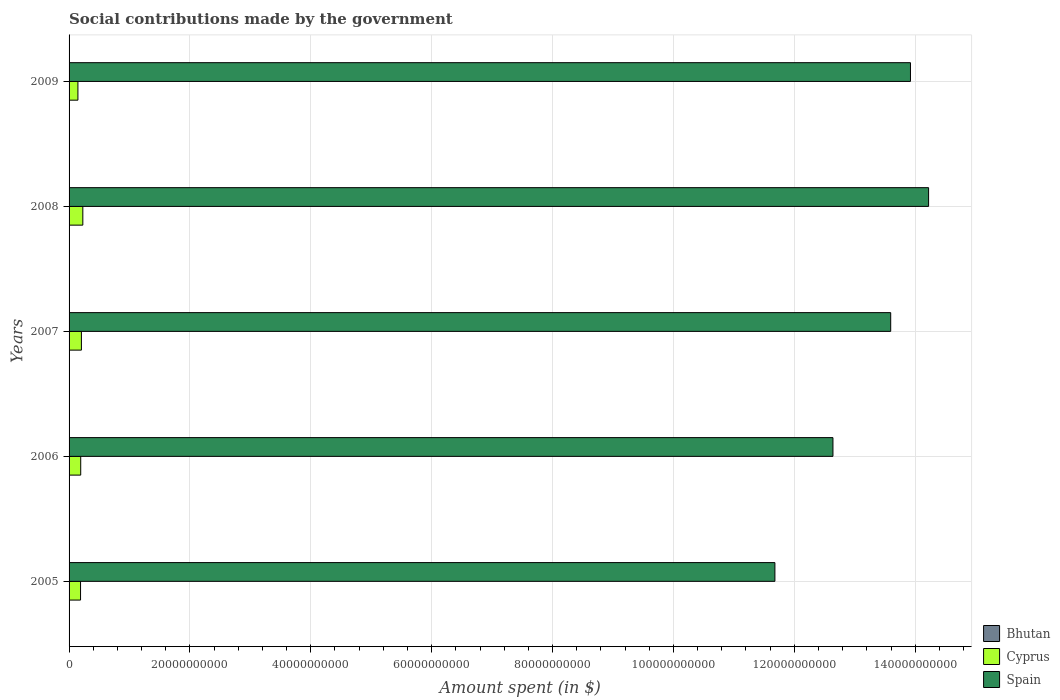How many different coloured bars are there?
Offer a terse response. 3. Are the number of bars per tick equal to the number of legend labels?
Offer a very short reply. Yes. How many bars are there on the 3rd tick from the top?
Your answer should be compact. 3. What is the amount spent on social contributions in Cyprus in 2008?
Ensure brevity in your answer.  2.28e+09. Across all years, what is the maximum amount spent on social contributions in Cyprus?
Keep it short and to the point. 2.28e+09. Across all years, what is the minimum amount spent on social contributions in Bhutan?
Provide a short and direct response. 3.60e+07. In which year was the amount spent on social contributions in Bhutan minimum?
Give a very brief answer. 2005. What is the total amount spent on social contributions in Spain in the graph?
Offer a very short reply. 6.61e+11. What is the difference between the amount spent on social contributions in Cyprus in 2008 and that in 2009?
Provide a short and direct response. 8.13e+08. What is the difference between the amount spent on social contributions in Bhutan in 2006 and the amount spent on social contributions in Cyprus in 2005?
Give a very brief answer. -1.85e+09. What is the average amount spent on social contributions in Spain per year?
Provide a succinct answer. 1.32e+11. In the year 2006, what is the difference between the amount spent on social contributions in Bhutan and amount spent on social contributions in Cyprus?
Provide a short and direct response. -1.88e+09. In how many years, is the amount spent on social contributions in Spain greater than 12000000000 $?
Your answer should be compact. 5. What is the ratio of the amount spent on social contributions in Bhutan in 2006 to that in 2007?
Offer a very short reply. 0.89. Is the amount spent on social contributions in Bhutan in 2006 less than that in 2007?
Provide a succinct answer. Yes. What is the difference between the highest and the second highest amount spent on social contributions in Cyprus?
Make the answer very short. 2.35e+08. What is the difference between the highest and the lowest amount spent on social contributions in Bhutan?
Your answer should be very brief. 3.53e+07. In how many years, is the amount spent on social contributions in Spain greater than the average amount spent on social contributions in Spain taken over all years?
Provide a short and direct response. 3. Is the sum of the amount spent on social contributions in Cyprus in 2005 and 2009 greater than the maximum amount spent on social contributions in Bhutan across all years?
Your answer should be compact. Yes. What does the 1st bar from the top in 2006 represents?
Your answer should be very brief. Spain. How many bars are there?
Make the answer very short. 15. Are all the bars in the graph horizontal?
Your response must be concise. Yes. Does the graph contain grids?
Offer a very short reply. Yes. Where does the legend appear in the graph?
Offer a terse response. Bottom right. How many legend labels are there?
Give a very brief answer. 3. How are the legend labels stacked?
Give a very brief answer. Vertical. What is the title of the graph?
Provide a short and direct response. Social contributions made by the government. What is the label or title of the X-axis?
Provide a succinct answer. Amount spent (in $). What is the label or title of the Y-axis?
Give a very brief answer. Years. What is the Amount spent (in $) in Bhutan in 2005?
Make the answer very short. 3.60e+07. What is the Amount spent (in $) in Cyprus in 2005?
Make the answer very short. 1.90e+09. What is the Amount spent (in $) of Spain in 2005?
Your answer should be compact. 1.17e+11. What is the Amount spent (in $) in Bhutan in 2006?
Your response must be concise. 4.41e+07. What is the Amount spent (in $) of Cyprus in 2006?
Make the answer very short. 1.93e+09. What is the Amount spent (in $) in Spain in 2006?
Offer a terse response. 1.26e+11. What is the Amount spent (in $) of Bhutan in 2007?
Offer a terse response. 4.94e+07. What is the Amount spent (in $) of Cyprus in 2007?
Your answer should be compact. 2.04e+09. What is the Amount spent (in $) in Spain in 2007?
Offer a very short reply. 1.36e+11. What is the Amount spent (in $) in Bhutan in 2008?
Keep it short and to the point. 5.82e+07. What is the Amount spent (in $) of Cyprus in 2008?
Offer a terse response. 2.28e+09. What is the Amount spent (in $) of Spain in 2008?
Ensure brevity in your answer.  1.42e+11. What is the Amount spent (in $) in Bhutan in 2009?
Your answer should be very brief. 7.13e+07. What is the Amount spent (in $) of Cyprus in 2009?
Make the answer very short. 1.46e+09. What is the Amount spent (in $) of Spain in 2009?
Your answer should be compact. 1.39e+11. Across all years, what is the maximum Amount spent (in $) of Bhutan?
Offer a terse response. 7.13e+07. Across all years, what is the maximum Amount spent (in $) in Cyprus?
Your answer should be compact. 2.28e+09. Across all years, what is the maximum Amount spent (in $) of Spain?
Make the answer very short. 1.42e+11. Across all years, what is the minimum Amount spent (in $) of Bhutan?
Offer a very short reply. 3.60e+07. Across all years, what is the minimum Amount spent (in $) of Cyprus?
Ensure brevity in your answer.  1.46e+09. Across all years, what is the minimum Amount spent (in $) in Spain?
Your response must be concise. 1.17e+11. What is the total Amount spent (in $) of Bhutan in the graph?
Your answer should be very brief. 2.59e+08. What is the total Amount spent (in $) of Cyprus in the graph?
Make the answer very short. 9.61e+09. What is the total Amount spent (in $) of Spain in the graph?
Provide a short and direct response. 6.61e+11. What is the difference between the Amount spent (in $) in Bhutan in 2005 and that in 2006?
Make the answer very short. -8.06e+06. What is the difference between the Amount spent (in $) of Cyprus in 2005 and that in 2006?
Provide a short and direct response. -3.02e+07. What is the difference between the Amount spent (in $) of Spain in 2005 and that in 2006?
Your answer should be compact. -9.61e+09. What is the difference between the Amount spent (in $) in Bhutan in 2005 and that in 2007?
Provide a short and direct response. -1.34e+07. What is the difference between the Amount spent (in $) in Cyprus in 2005 and that in 2007?
Provide a short and direct response. -1.44e+08. What is the difference between the Amount spent (in $) of Spain in 2005 and that in 2007?
Make the answer very short. -1.92e+1. What is the difference between the Amount spent (in $) in Bhutan in 2005 and that in 2008?
Ensure brevity in your answer.  -2.22e+07. What is the difference between the Amount spent (in $) of Cyprus in 2005 and that in 2008?
Keep it short and to the point. -3.79e+08. What is the difference between the Amount spent (in $) in Spain in 2005 and that in 2008?
Give a very brief answer. -2.54e+1. What is the difference between the Amount spent (in $) in Bhutan in 2005 and that in 2009?
Offer a very short reply. -3.53e+07. What is the difference between the Amount spent (in $) of Cyprus in 2005 and that in 2009?
Give a very brief answer. 4.34e+08. What is the difference between the Amount spent (in $) of Spain in 2005 and that in 2009?
Ensure brevity in your answer.  -2.24e+1. What is the difference between the Amount spent (in $) of Bhutan in 2006 and that in 2007?
Ensure brevity in your answer.  -5.36e+06. What is the difference between the Amount spent (in $) in Cyprus in 2006 and that in 2007?
Make the answer very short. -1.13e+08. What is the difference between the Amount spent (in $) of Spain in 2006 and that in 2007?
Offer a very short reply. -9.56e+09. What is the difference between the Amount spent (in $) in Bhutan in 2006 and that in 2008?
Offer a terse response. -1.41e+07. What is the difference between the Amount spent (in $) of Cyprus in 2006 and that in 2008?
Offer a very short reply. -3.49e+08. What is the difference between the Amount spent (in $) in Spain in 2006 and that in 2008?
Provide a short and direct response. -1.58e+1. What is the difference between the Amount spent (in $) in Bhutan in 2006 and that in 2009?
Make the answer very short. -2.72e+07. What is the difference between the Amount spent (in $) of Cyprus in 2006 and that in 2009?
Your answer should be compact. 4.64e+08. What is the difference between the Amount spent (in $) in Spain in 2006 and that in 2009?
Offer a terse response. -1.28e+1. What is the difference between the Amount spent (in $) in Bhutan in 2007 and that in 2008?
Provide a short and direct response. -8.78e+06. What is the difference between the Amount spent (in $) of Cyprus in 2007 and that in 2008?
Provide a short and direct response. -2.35e+08. What is the difference between the Amount spent (in $) in Spain in 2007 and that in 2008?
Make the answer very short. -6.27e+09. What is the difference between the Amount spent (in $) of Bhutan in 2007 and that in 2009?
Provide a short and direct response. -2.19e+07. What is the difference between the Amount spent (in $) in Cyprus in 2007 and that in 2009?
Give a very brief answer. 5.77e+08. What is the difference between the Amount spent (in $) in Spain in 2007 and that in 2009?
Your response must be concise. -3.27e+09. What is the difference between the Amount spent (in $) of Bhutan in 2008 and that in 2009?
Provide a short and direct response. -1.31e+07. What is the difference between the Amount spent (in $) in Cyprus in 2008 and that in 2009?
Provide a succinct answer. 8.13e+08. What is the difference between the Amount spent (in $) of Spain in 2008 and that in 2009?
Offer a very short reply. 3.00e+09. What is the difference between the Amount spent (in $) in Bhutan in 2005 and the Amount spent (in $) in Cyprus in 2006?
Ensure brevity in your answer.  -1.89e+09. What is the difference between the Amount spent (in $) in Bhutan in 2005 and the Amount spent (in $) in Spain in 2006?
Keep it short and to the point. -1.26e+11. What is the difference between the Amount spent (in $) of Cyprus in 2005 and the Amount spent (in $) of Spain in 2006?
Make the answer very short. -1.24e+11. What is the difference between the Amount spent (in $) in Bhutan in 2005 and the Amount spent (in $) in Cyprus in 2007?
Keep it short and to the point. -2.01e+09. What is the difference between the Amount spent (in $) in Bhutan in 2005 and the Amount spent (in $) in Spain in 2007?
Give a very brief answer. -1.36e+11. What is the difference between the Amount spent (in $) of Cyprus in 2005 and the Amount spent (in $) of Spain in 2007?
Give a very brief answer. -1.34e+11. What is the difference between the Amount spent (in $) of Bhutan in 2005 and the Amount spent (in $) of Cyprus in 2008?
Provide a short and direct response. -2.24e+09. What is the difference between the Amount spent (in $) of Bhutan in 2005 and the Amount spent (in $) of Spain in 2008?
Your answer should be compact. -1.42e+11. What is the difference between the Amount spent (in $) in Cyprus in 2005 and the Amount spent (in $) in Spain in 2008?
Keep it short and to the point. -1.40e+11. What is the difference between the Amount spent (in $) in Bhutan in 2005 and the Amount spent (in $) in Cyprus in 2009?
Your answer should be very brief. -1.43e+09. What is the difference between the Amount spent (in $) in Bhutan in 2005 and the Amount spent (in $) in Spain in 2009?
Provide a succinct answer. -1.39e+11. What is the difference between the Amount spent (in $) of Cyprus in 2005 and the Amount spent (in $) of Spain in 2009?
Give a very brief answer. -1.37e+11. What is the difference between the Amount spent (in $) in Bhutan in 2006 and the Amount spent (in $) in Cyprus in 2007?
Give a very brief answer. -2.00e+09. What is the difference between the Amount spent (in $) of Bhutan in 2006 and the Amount spent (in $) of Spain in 2007?
Your answer should be compact. -1.36e+11. What is the difference between the Amount spent (in $) of Cyprus in 2006 and the Amount spent (in $) of Spain in 2007?
Offer a terse response. -1.34e+11. What is the difference between the Amount spent (in $) of Bhutan in 2006 and the Amount spent (in $) of Cyprus in 2008?
Offer a very short reply. -2.23e+09. What is the difference between the Amount spent (in $) of Bhutan in 2006 and the Amount spent (in $) of Spain in 2008?
Your response must be concise. -1.42e+11. What is the difference between the Amount spent (in $) in Cyprus in 2006 and the Amount spent (in $) in Spain in 2008?
Provide a succinct answer. -1.40e+11. What is the difference between the Amount spent (in $) in Bhutan in 2006 and the Amount spent (in $) in Cyprus in 2009?
Your response must be concise. -1.42e+09. What is the difference between the Amount spent (in $) in Bhutan in 2006 and the Amount spent (in $) in Spain in 2009?
Give a very brief answer. -1.39e+11. What is the difference between the Amount spent (in $) of Cyprus in 2006 and the Amount spent (in $) of Spain in 2009?
Provide a short and direct response. -1.37e+11. What is the difference between the Amount spent (in $) of Bhutan in 2007 and the Amount spent (in $) of Cyprus in 2008?
Provide a succinct answer. -2.23e+09. What is the difference between the Amount spent (in $) of Bhutan in 2007 and the Amount spent (in $) of Spain in 2008?
Your answer should be compact. -1.42e+11. What is the difference between the Amount spent (in $) of Cyprus in 2007 and the Amount spent (in $) of Spain in 2008?
Ensure brevity in your answer.  -1.40e+11. What is the difference between the Amount spent (in $) of Bhutan in 2007 and the Amount spent (in $) of Cyprus in 2009?
Offer a very short reply. -1.41e+09. What is the difference between the Amount spent (in $) of Bhutan in 2007 and the Amount spent (in $) of Spain in 2009?
Offer a terse response. -1.39e+11. What is the difference between the Amount spent (in $) of Cyprus in 2007 and the Amount spent (in $) of Spain in 2009?
Your response must be concise. -1.37e+11. What is the difference between the Amount spent (in $) in Bhutan in 2008 and the Amount spent (in $) in Cyprus in 2009?
Your answer should be compact. -1.41e+09. What is the difference between the Amount spent (in $) in Bhutan in 2008 and the Amount spent (in $) in Spain in 2009?
Provide a succinct answer. -1.39e+11. What is the difference between the Amount spent (in $) of Cyprus in 2008 and the Amount spent (in $) of Spain in 2009?
Provide a succinct answer. -1.37e+11. What is the average Amount spent (in $) in Bhutan per year?
Provide a succinct answer. 5.18e+07. What is the average Amount spent (in $) in Cyprus per year?
Give a very brief answer. 1.92e+09. What is the average Amount spent (in $) in Spain per year?
Provide a succinct answer. 1.32e+11. In the year 2005, what is the difference between the Amount spent (in $) in Bhutan and Amount spent (in $) in Cyprus?
Ensure brevity in your answer.  -1.86e+09. In the year 2005, what is the difference between the Amount spent (in $) in Bhutan and Amount spent (in $) in Spain?
Provide a short and direct response. -1.17e+11. In the year 2005, what is the difference between the Amount spent (in $) in Cyprus and Amount spent (in $) in Spain?
Your answer should be very brief. -1.15e+11. In the year 2006, what is the difference between the Amount spent (in $) in Bhutan and Amount spent (in $) in Cyprus?
Give a very brief answer. -1.88e+09. In the year 2006, what is the difference between the Amount spent (in $) in Bhutan and Amount spent (in $) in Spain?
Offer a terse response. -1.26e+11. In the year 2006, what is the difference between the Amount spent (in $) in Cyprus and Amount spent (in $) in Spain?
Offer a terse response. -1.24e+11. In the year 2007, what is the difference between the Amount spent (in $) of Bhutan and Amount spent (in $) of Cyprus?
Give a very brief answer. -1.99e+09. In the year 2007, what is the difference between the Amount spent (in $) of Bhutan and Amount spent (in $) of Spain?
Provide a succinct answer. -1.36e+11. In the year 2007, what is the difference between the Amount spent (in $) of Cyprus and Amount spent (in $) of Spain?
Give a very brief answer. -1.34e+11. In the year 2008, what is the difference between the Amount spent (in $) in Bhutan and Amount spent (in $) in Cyprus?
Offer a very short reply. -2.22e+09. In the year 2008, what is the difference between the Amount spent (in $) in Bhutan and Amount spent (in $) in Spain?
Your response must be concise. -1.42e+11. In the year 2008, what is the difference between the Amount spent (in $) in Cyprus and Amount spent (in $) in Spain?
Provide a short and direct response. -1.40e+11. In the year 2009, what is the difference between the Amount spent (in $) in Bhutan and Amount spent (in $) in Cyprus?
Offer a very short reply. -1.39e+09. In the year 2009, what is the difference between the Amount spent (in $) of Bhutan and Amount spent (in $) of Spain?
Provide a succinct answer. -1.39e+11. In the year 2009, what is the difference between the Amount spent (in $) of Cyprus and Amount spent (in $) of Spain?
Your answer should be very brief. -1.38e+11. What is the ratio of the Amount spent (in $) in Bhutan in 2005 to that in 2006?
Keep it short and to the point. 0.82. What is the ratio of the Amount spent (in $) of Cyprus in 2005 to that in 2006?
Your response must be concise. 0.98. What is the ratio of the Amount spent (in $) of Spain in 2005 to that in 2006?
Ensure brevity in your answer.  0.92. What is the ratio of the Amount spent (in $) in Bhutan in 2005 to that in 2007?
Provide a short and direct response. 0.73. What is the ratio of the Amount spent (in $) of Cyprus in 2005 to that in 2007?
Keep it short and to the point. 0.93. What is the ratio of the Amount spent (in $) of Spain in 2005 to that in 2007?
Provide a succinct answer. 0.86. What is the ratio of the Amount spent (in $) in Bhutan in 2005 to that in 2008?
Give a very brief answer. 0.62. What is the ratio of the Amount spent (in $) in Cyprus in 2005 to that in 2008?
Your answer should be very brief. 0.83. What is the ratio of the Amount spent (in $) in Spain in 2005 to that in 2008?
Keep it short and to the point. 0.82. What is the ratio of the Amount spent (in $) in Bhutan in 2005 to that in 2009?
Your response must be concise. 0.51. What is the ratio of the Amount spent (in $) of Cyprus in 2005 to that in 2009?
Provide a succinct answer. 1.3. What is the ratio of the Amount spent (in $) in Spain in 2005 to that in 2009?
Provide a short and direct response. 0.84. What is the ratio of the Amount spent (in $) of Bhutan in 2006 to that in 2007?
Provide a short and direct response. 0.89. What is the ratio of the Amount spent (in $) in Cyprus in 2006 to that in 2007?
Provide a succinct answer. 0.94. What is the ratio of the Amount spent (in $) of Spain in 2006 to that in 2007?
Give a very brief answer. 0.93. What is the ratio of the Amount spent (in $) of Bhutan in 2006 to that in 2008?
Offer a terse response. 0.76. What is the ratio of the Amount spent (in $) in Cyprus in 2006 to that in 2008?
Provide a succinct answer. 0.85. What is the ratio of the Amount spent (in $) of Spain in 2006 to that in 2008?
Your response must be concise. 0.89. What is the ratio of the Amount spent (in $) of Bhutan in 2006 to that in 2009?
Provide a succinct answer. 0.62. What is the ratio of the Amount spent (in $) of Cyprus in 2006 to that in 2009?
Make the answer very short. 1.32. What is the ratio of the Amount spent (in $) in Spain in 2006 to that in 2009?
Your answer should be very brief. 0.91. What is the ratio of the Amount spent (in $) in Bhutan in 2007 to that in 2008?
Your response must be concise. 0.85. What is the ratio of the Amount spent (in $) in Cyprus in 2007 to that in 2008?
Give a very brief answer. 0.9. What is the ratio of the Amount spent (in $) in Spain in 2007 to that in 2008?
Your response must be concise. 0.96. What is the ratio of the Amount spent (in $) of Bhutan in 2007 to that in 2009?
Keep it short and to the point. 0.69. What is the ratio of the Amount spent (in $) in Cyprus in 2007 to that in 2009?
Offer a very short reply. 1.39. What is the ratio of the Amount spent (in $) of Spain in 2007 to that in 2009?
Provide a succinct answer. 0.98. What is the ratio of the Amount spent (in $) in Bhutan in 2008 to that in 2009?
Your response must be concise. 0.82. What is the ratio of the Amount spent (in $) of Cyprus in 2008 to that in 2009?
Make the answer very short. 1.55. What is the ratio of the Amount spent (in $) in Spain in 2008 to that in 2009?
Your response must be concise. 1.02. What is the difference between the highest and the second highest Amount spent (in $) in Bhutan?
Offer a very short reply. 1.31e+07. What is the difference between the highest and the second highest Amount spent (in $) of Cyprus?
Provide a short and direct response. 2.35e+08. What is the difference between the highest and the second highest Amount spent (in $) in Spain?
Provide a short and direct response. 3.00e+09. What is the difference between the highest and the lowest Amount spent (in $) in Bhutan?
Your answer should be very brief. 3.53e+07. What is the difference between the highest and the lowest Amount spent (in $) of Cyprus?
Give a very brief answer. 8.13e+08. What is the difference between the highest and the lowest Amount spent (in $) in Spain?
Your response must be concise. 2.54e+1. 